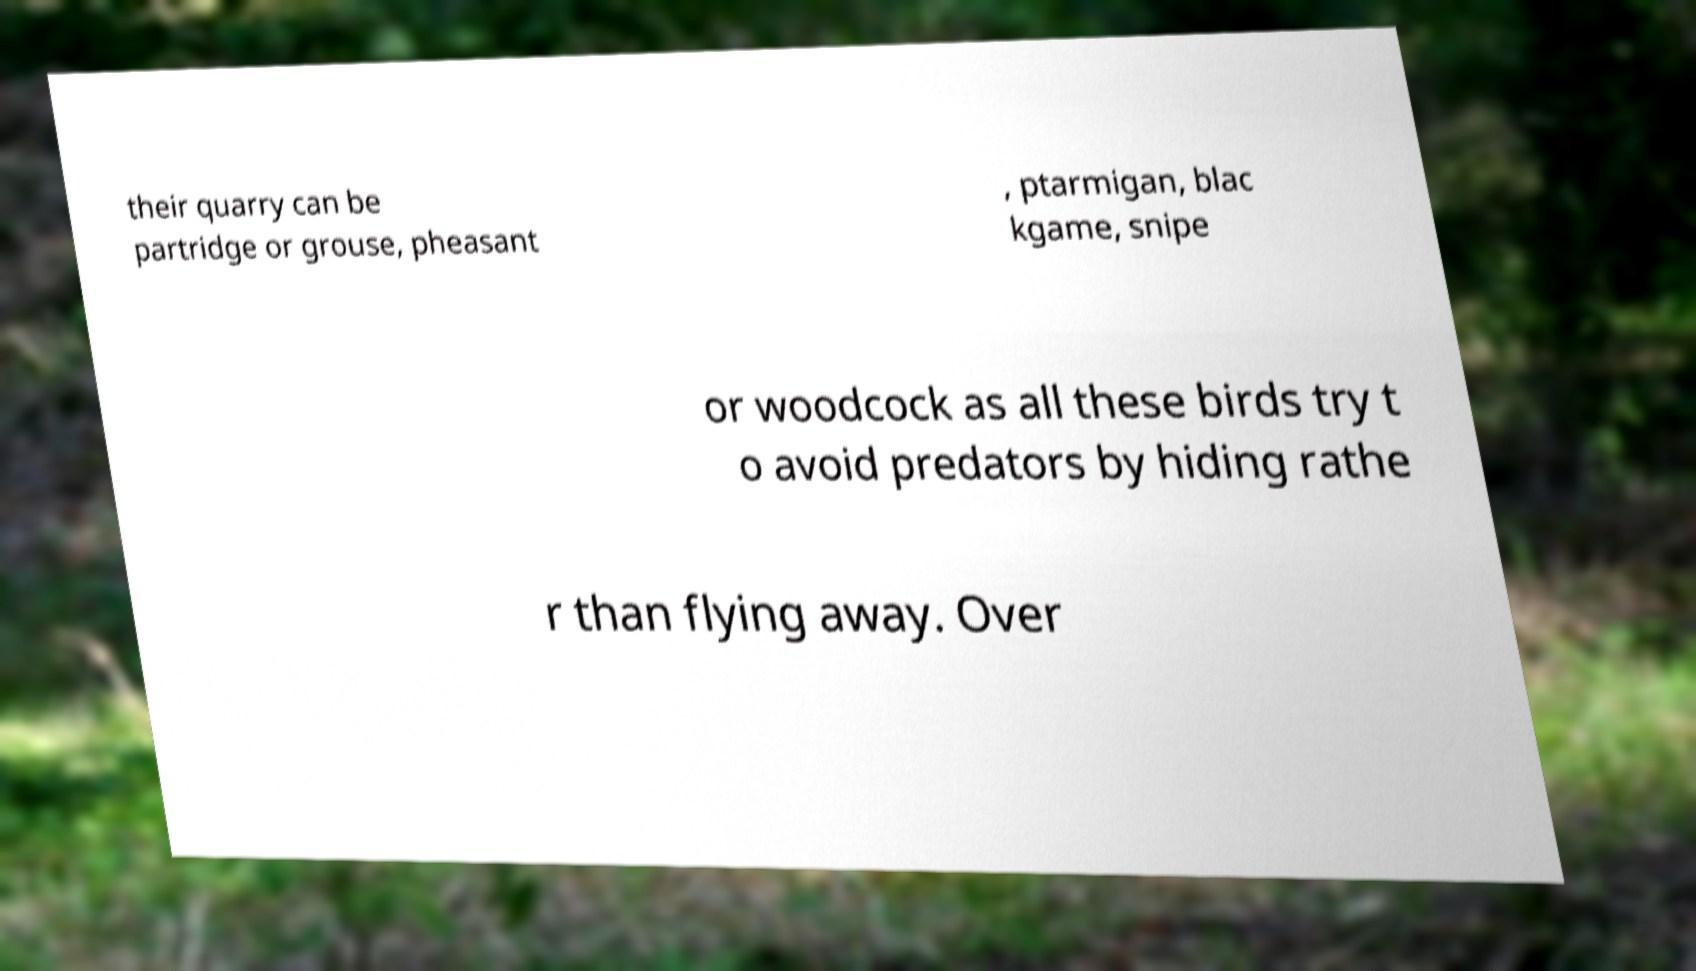What messages or text are displayed in this image? I need them in a readable, typed format. their quarry can be partridge or grouse, pheasant , ptarmigan, blac kgame, snipe or woodcock as all these birds try t o avoid predators by hiding rathe r than flying away. Over 